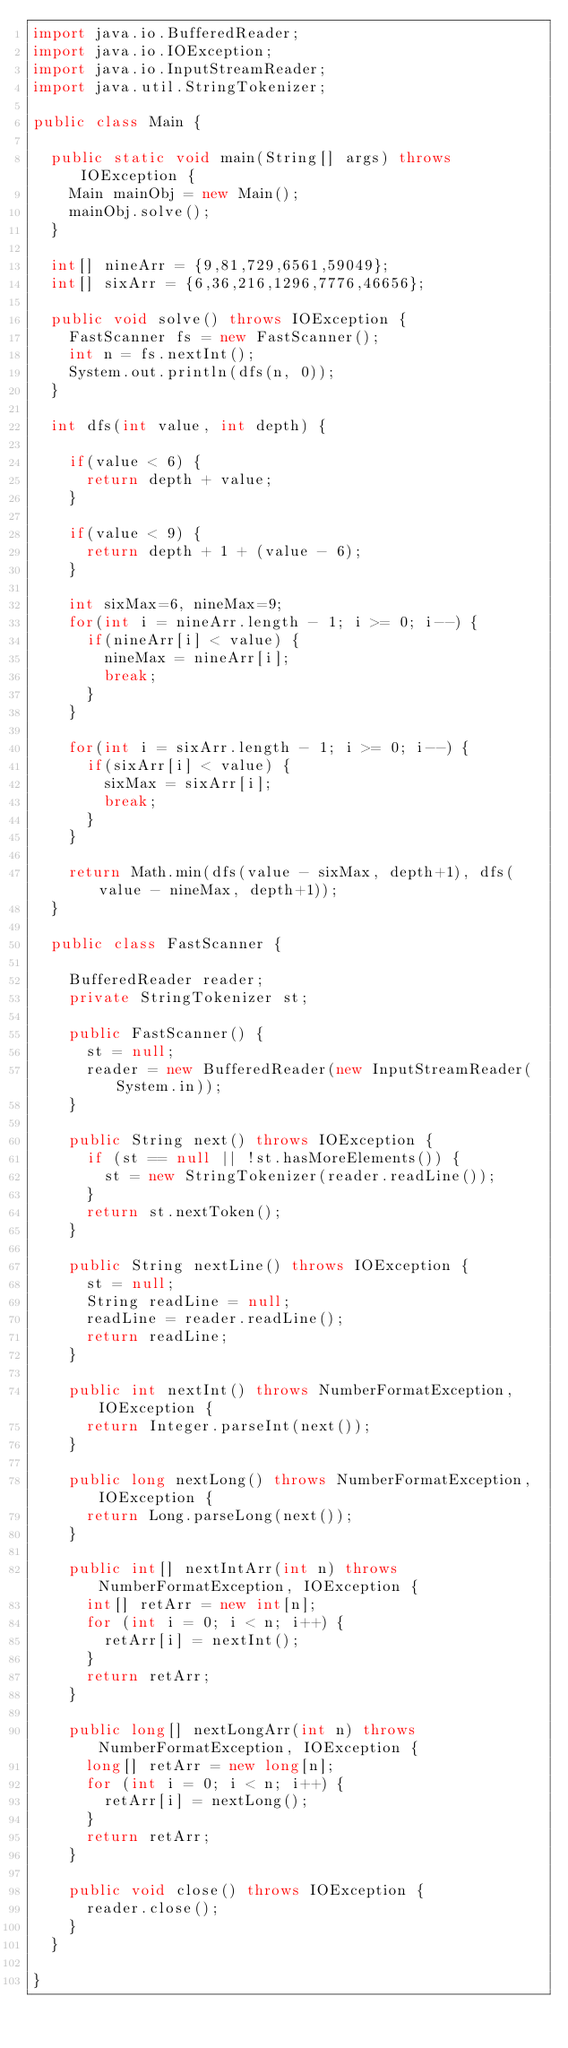<code> <loc_0><loc_0><loc_500><loc_500><_Java_>import java.io.BufferedReader;
import java.io.IOException;
import java.io.InputStreamReader;
import java.util.StringTokenizer;

public class Main {

	public static void main(String[] args) throws IOException {
		Main mainObj = new Main();
		mainObj.solve();
	}

	int[] nineArr = {9,81,729,6561,59049};
	int[] sixArr = {6,36,216,1296,7776,46656};
	
	public void solve() throws IOException {
		FastScanner fs = new FastScanner();
		int n = fs.nextInt();
		System.out.println(dfs(n, 0));
	}
	
	int dfs(int value, int depth) {
		
		if(value < 6) {
			return depth + value;
		}
		
		if(value < 9) {
			return depth + 1 + (value - 6);
		}
		
		int sixMax=6, nineMax=9;
		for(int i = nineArr.length - 1; i >= 0; i--) {
			if(nineArr[i] < value) {
				nineMax = nineArr[i];
				break;
			}
		}
		
		for(int i = sixArr.length - 1; i >= 0; i--) {
			if(sixArr[i] < value) {
				sixMax = sixArr[i];
				break;
			}
		}
		
		return Math.min(dfs(value - sixMax, depth+1), dfs(value - nineMax, depth+1));
	}

	public class FastScanner {

		BufferedReader reader;
		private StringTokenizer st;

		public FastScanner() {
			st = null;
			reader = new BufferedReader(new InputStreamReader(System.in));
		}

		public String next() throws IOException {
			if (st == null || !st.hasMoreElements()) {
				st = new StringTokenizer(reader.readLine());
			}
			return st.nextToken();
		}

		public String nextLine() throws IOException {
			st = null;
			String readLine = null;
			readLine = reader.readLine();
			return readLine;
		}

		public int nextInt() throws NumberFormatException, IOException {
			return Integer.parseInt(next());
		}

		public long nextLong() throws NumberFormatException, IOException {
			return Long.parseLong(next());
		}

		public int[] nextIntArr(int n) throws NumberFormatException, IOException {
			int[] retArr = new int[n];
			for (int i = 0; i < n; i++) {
				retArr[i] = nextInt();
			}
			return retArr;
		}

		public long[] nextLongArr(int n) throws NumberFormatException, IOException {
			long[] retArr = new long[n];
			for (int i = 0; i < n; i++) {
				retArr[i] = nextLong();
			}
			return retArr;
		}

		public void close() throws IOException {
			reader.close();
		}
	}

}
</code> 